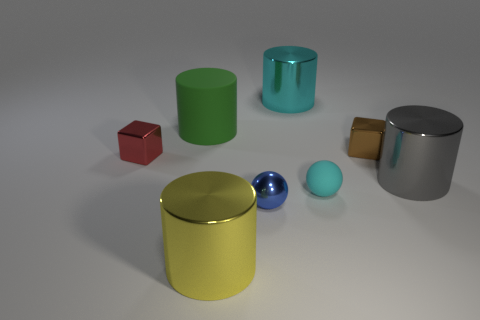Add 1 large cyan shiny things. How many objects exist? 9 Subtract all blocks. How many objects are left? 6 Subtract all blocks. Subtract all cyan things. How many objects are left? 4 Add 6 big green matte cylinders. How many big green matte cylinders are left? 7 Add 3 blocks. How many blocks exist? 5 Subtract 0 brown cylinders. How many objects are left? 8 